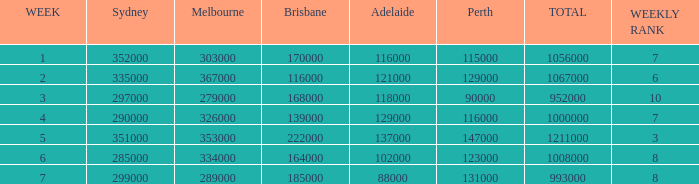What was the number of adelaide viewers in week 5? 137000.0. 